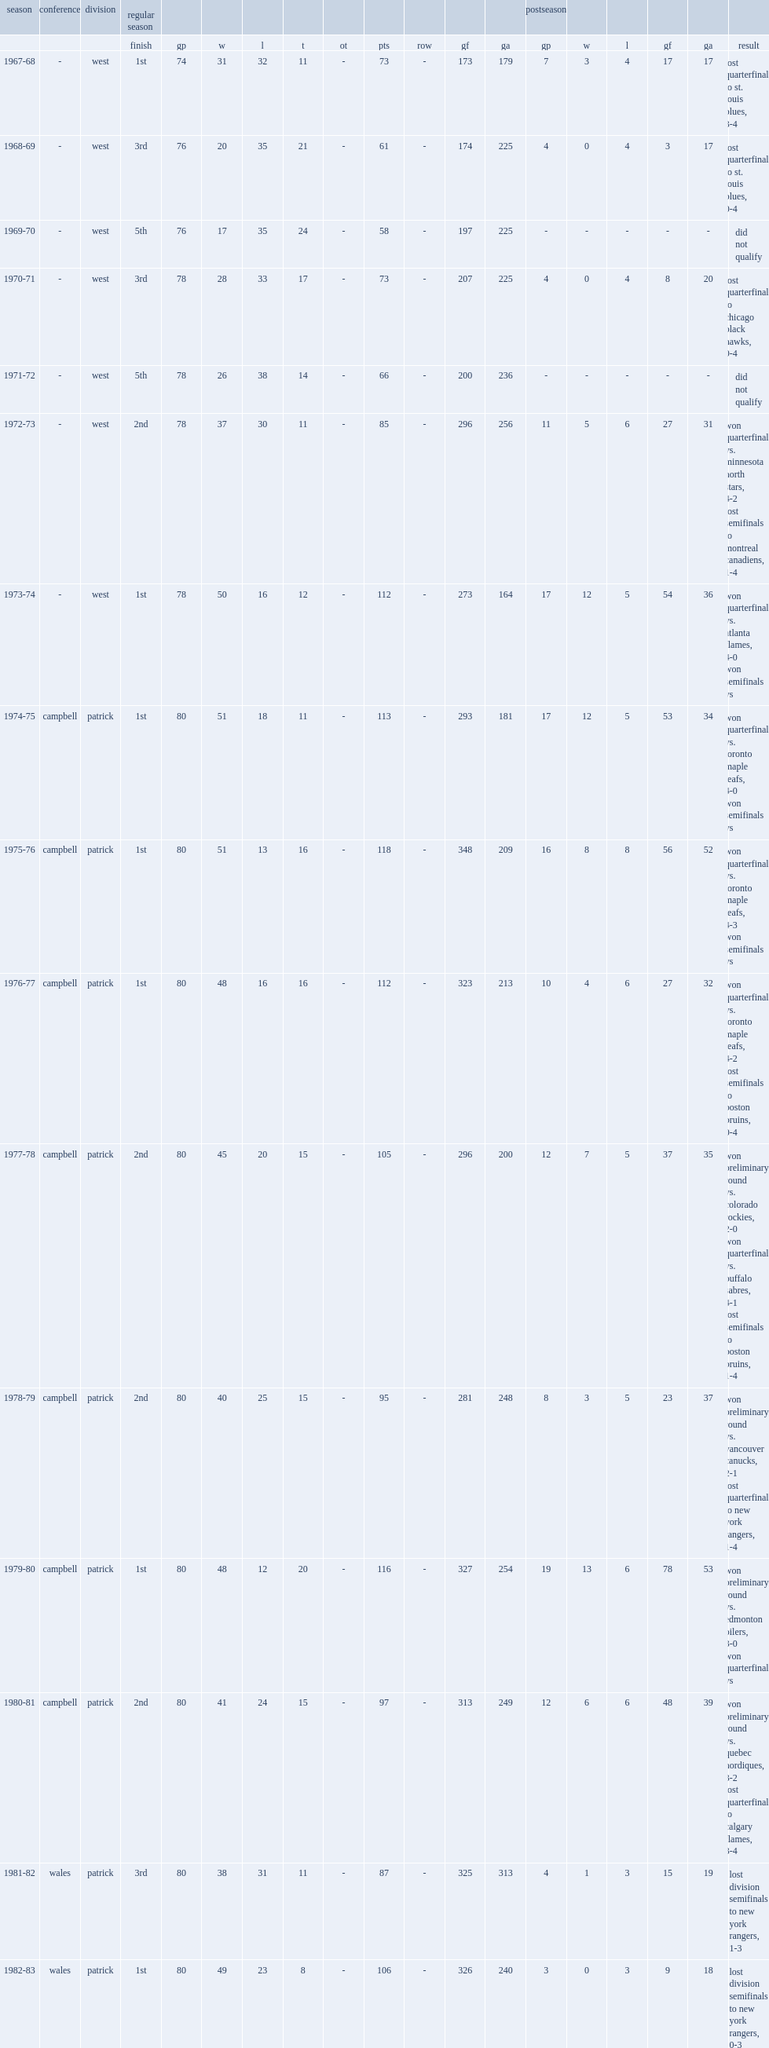How many seasons are before the 2015-16 philadelphia flyers season? 41.0. 